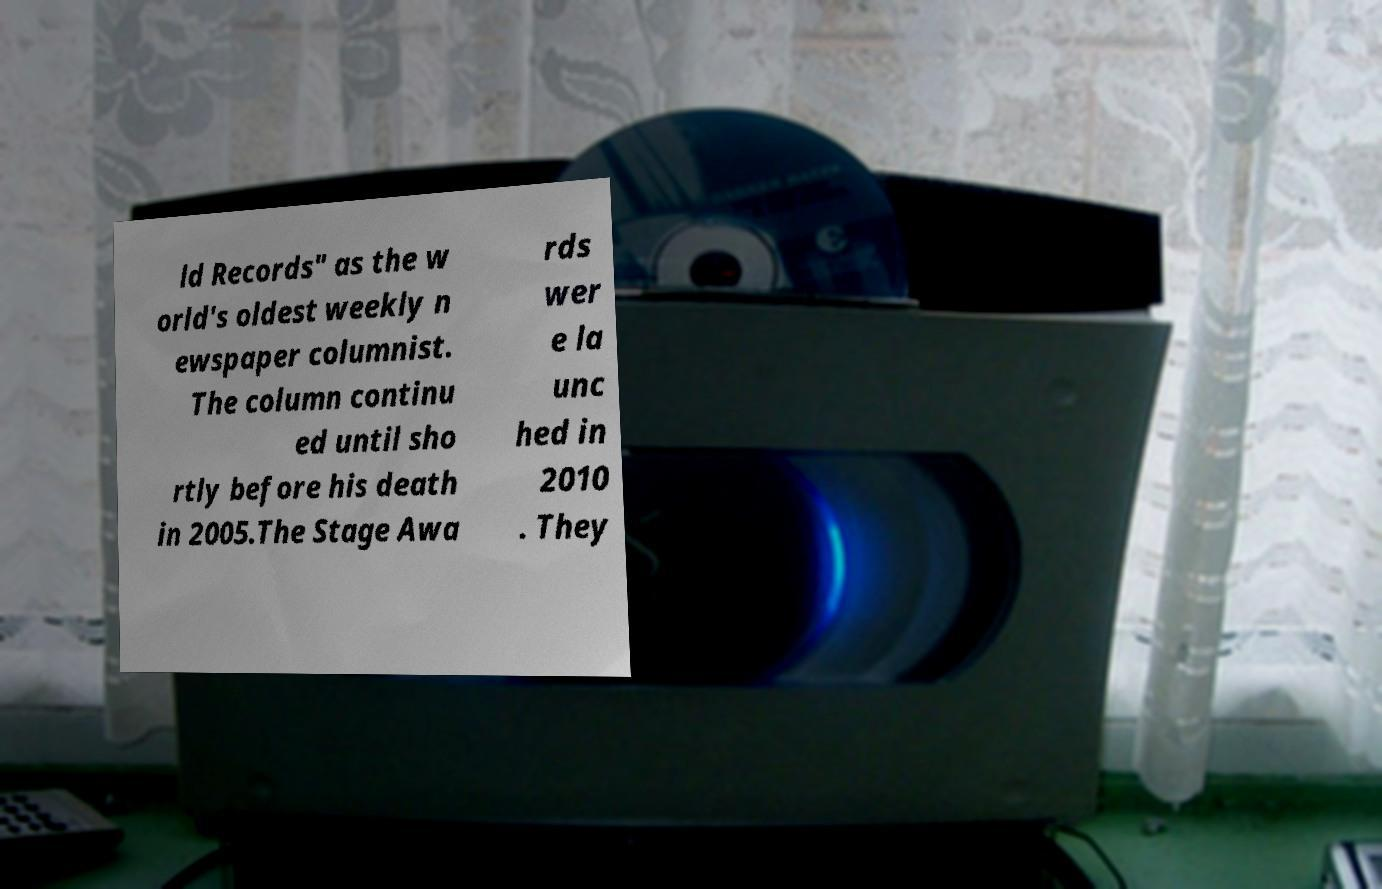Could you extract and type out the text from this image? ld Records" as the w orld's oldest weekly n ewspaper columnist. The column continu ed until sho rtly before his death in 2005.The Stage Awa rds wer e la unc hed in 2010 . They 